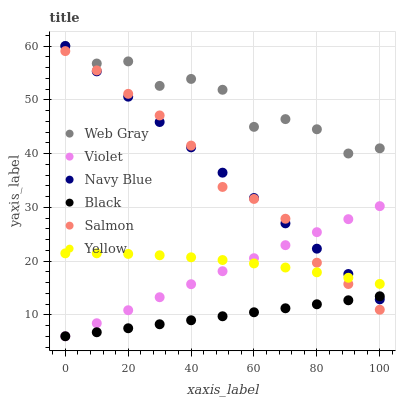Does Black have the minimum area under the curve?
Answer yes or no. Yes. Does Web Gray have the maximum area under the curve?
Answer yes or no. Yes. Does Navy Blue have the minimum area under the curve?
Answer yes or no. No. Does Navy Blue have the maximum area under the curve?
Answer yes or no. No. Is Black the smoothest?
Answer yes or no. Yes. Is Web Gray the roughest?
Answer yes or no. Yes. Is Navy Blue the smoothest?
Answer yes or no. No. Is Navy Blue the roughest?
Answer yes or no. No. Does Black have the lowest value?
Answer yes or no. Yes. Does Navy Blue have the lowest value?
Answer yes or no. No. Does Navy Blue have the highest value?
Answer yes or no. Yes. Does Salmon have the highest value?
Answer yes or no. No. Is Black less than Web Gray?
Answer yes or no. Yes. Is Web Gray greater than Salmon?
Answer yes or no. Yes. Does Navy Blue intersect Violet?
Answer yes or no. Yes. Is Navy Blue less than Violet?
Answer yes or no. No. Is Navy Blue greater than Violet?
Answer yes or no. No. Does Black intersect Web Gray?
Answer yes or no. No. 